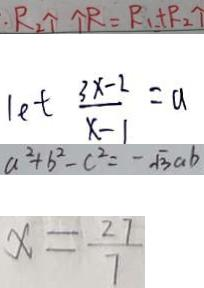Convert formula to latex. <formula><loc_0><loc_0><loc_500><loc_500>\cdot R _ { 2 } \uparrow \uparrow R = R _ { 1 } + P _ { 2 } \uparrow 
 1 e t \frac { 3 x - 2 } { x - 1 } = a 
 a ^ { 2 } + b ^ { 2 } - c ^ { 2 } = - \sqrt { 3 } a b 
 x = \frac { 2 7 } { 7 }</formula> 